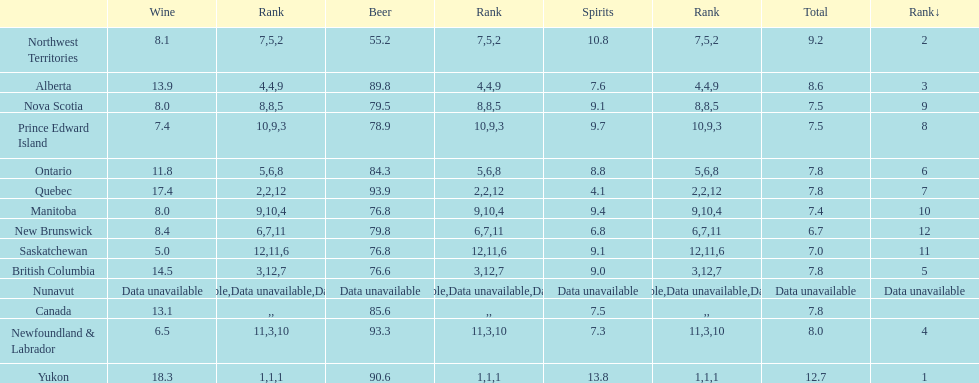Which province is the top consumer of wine? Yukon. 